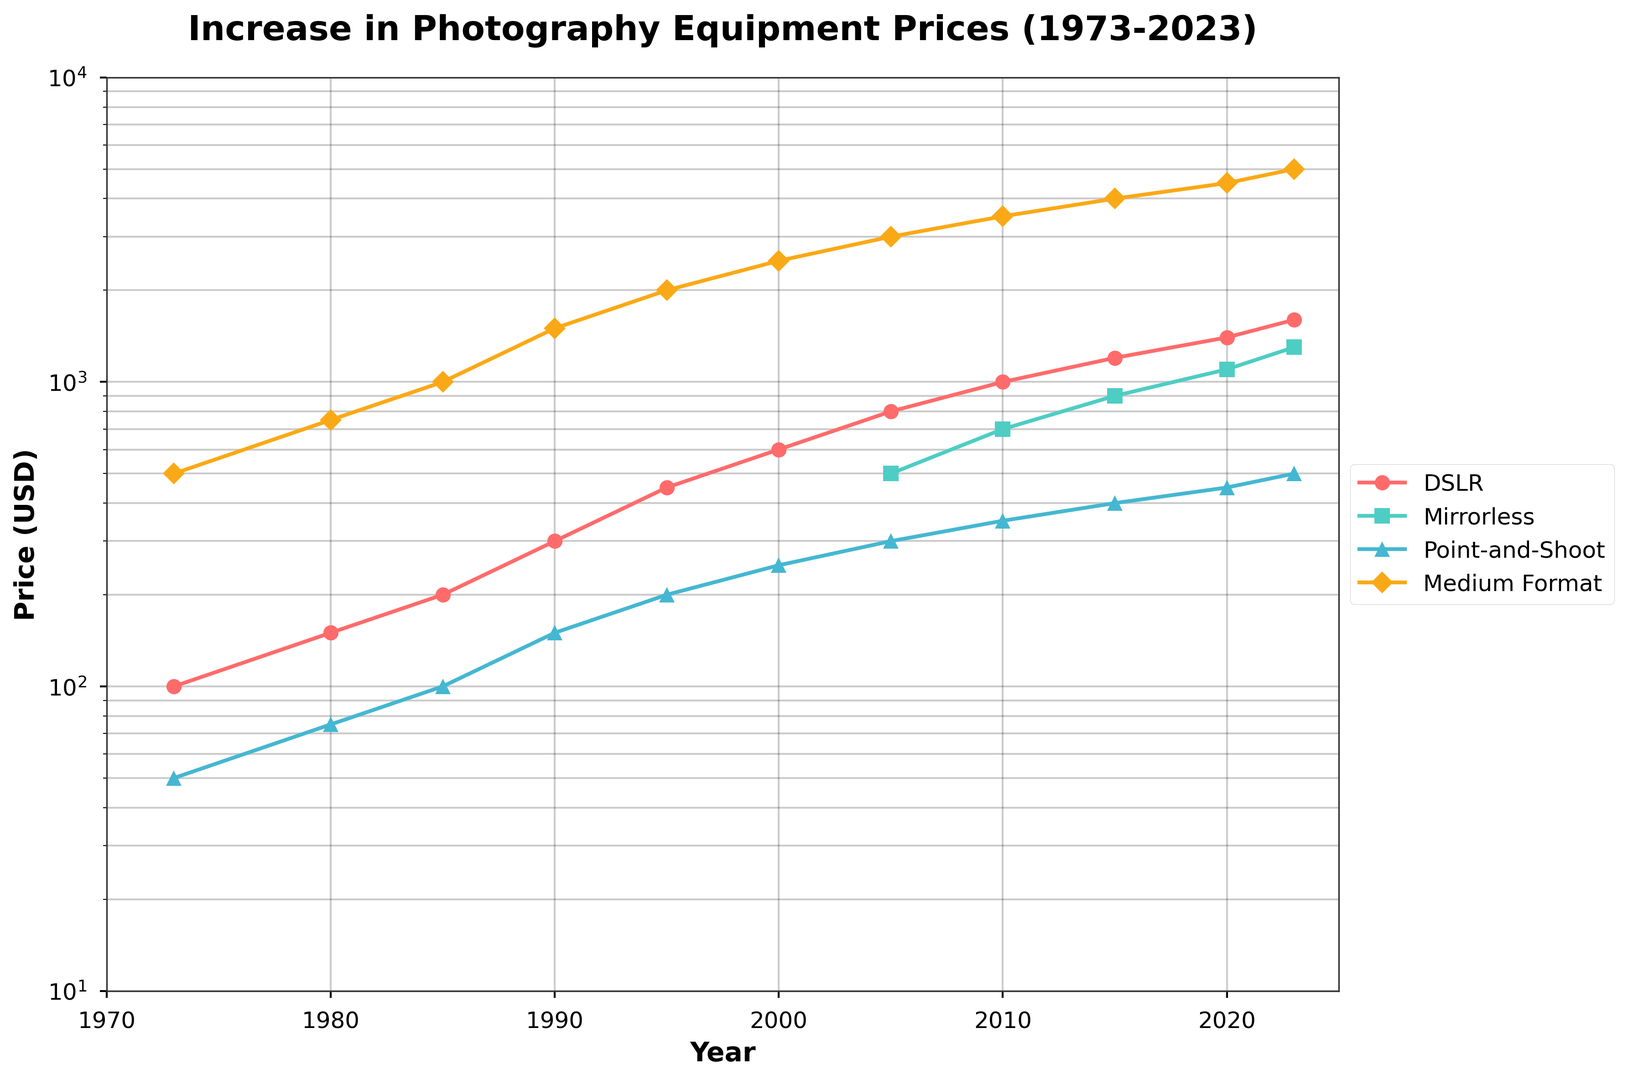What is the price of a DSLR camera in 1973? The price of a DSLR camera in 1973 is directly shown on the y-axis value corresponding to the year 1973 in the figure for the DSLR line.
Answer: 100 Which camera type has seen the highest increase in price from 1973 to 2023? Look at the last data points for each camera type in 2023 and subtract the corresponding initial data points in 1973, then identify the camera type with the largest difference.
Answer: Medium Format What is the average price of a Point-and-Shoot camera from 1985 to 2005? Sum the prices of the Point-and-Shoot camera for the years 1985, 1990, 1995, 2000, and 2005, then divide by 5. The prices are 100, 150, 200, 250, and 300, respectively. (100 + 150 + 200 + 250 + 300) / 5 = 200
Answer: 200 When comparing Mirrorless and Point-and-Shoot cameras in 2015, which one is more expensive and by how much? Check the y-axis values for Mirrorless and Point-and-Shoot cameras in 2015. The prices are 900 and 400, respectively. The difference is 900 - 400 = 500
Answer: Mirrorless by 500 How does the price trend of DSLR cameras compare to Mirrorless cameras from 2005 to 2023? Observe the curves for both DSLR and Mirrorless cameras from 2005 to 2023. Determine if their slopes (indicative of growth rate) are parallel or if one is steeper. The DSLR camera curve shows a steeper upward slope, indicating a faster price increase compared to Mirrorless cameras.
Answer: DSLR has a steeper increase In which year did Medium Format cameras first reach a price of $2000? Locate the intersection of the Medium Format camera line with the $2000 line on the y-axis. The crossing occurs around 1995.
Answer: 1995 What is the ratio of the price of a Medium Format camera to a DSLR camera in 2020? Find the prices of both Medium Format and DSLR cameras in 2020. The prices are 4500 and 1400, respectively. Then compute the ratio 4500 / 1400 ≈ 3.21
Answer: 3.21 By which year did Mirrorless cameras become more expensive than Point-and-Shoot cameras? Identify the year in which the Mirrorless camera line crosses above the Point-and-Shoot camera line. This crossover occurs around 2010.
Answer: 2010 What is the price difference between Medium Format cameras and Point-and-Shoot cameras in 2000? Obtain the prices of Medium Format and Point-and-Shoot cameras for the year 2000. The prices are 2500 and 250, respectively. The difference is 2500 - 250 = 2250
Answer: 2250 Which camera type had the steepest price increase between any two consecutive data points? Examine the slopes between consecutive points for each camera type and identify the steepest increase. The steepest jump appears between two consecutive Medium Format camera prices. For instance, the difference from 1973 ($500) to 1980 ($750) is $250, and similar significant jumps appear between some points.
Answer: Medium Format 